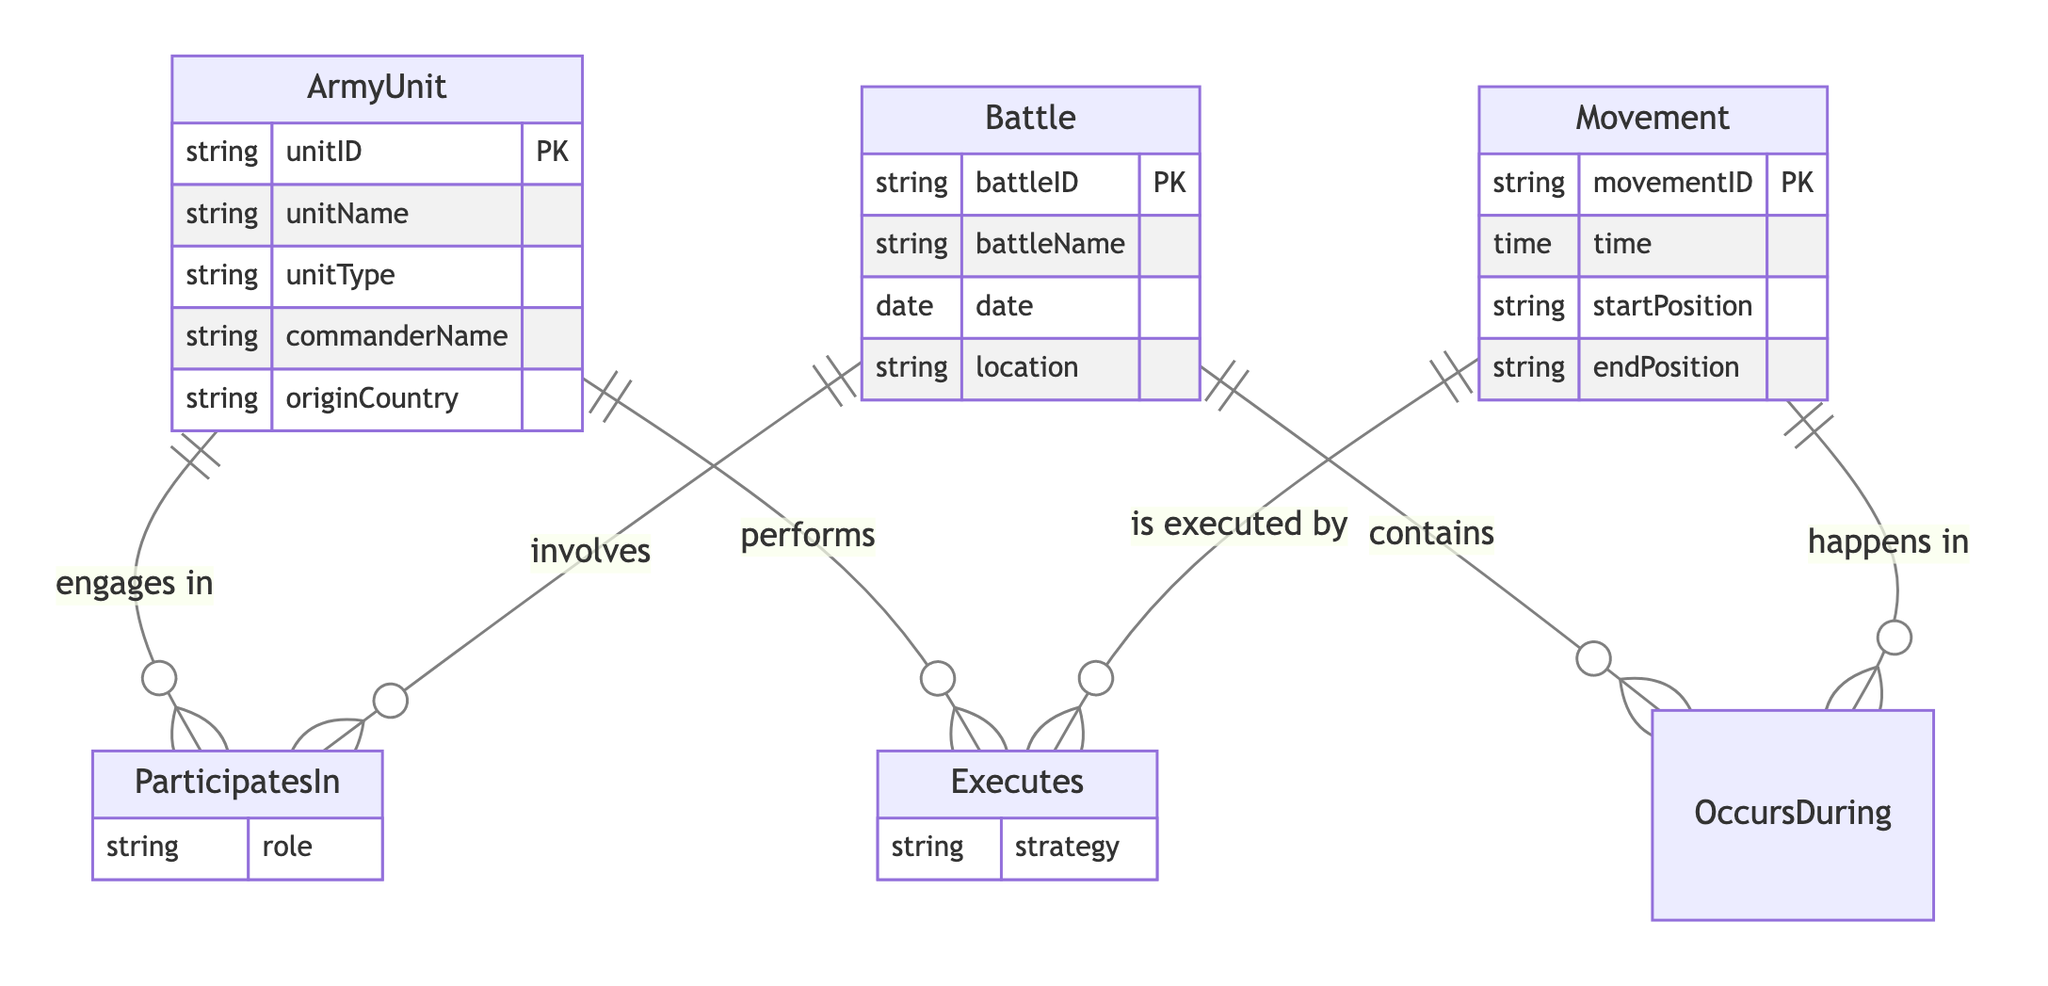what are the attributes of the Battle entity? The attributes for the Battle entity, as shown in the diagram, include battleID, battleName, date, and location.
Answer: battleID, battleName, date, location how many entities are in the diagram? By counting the entities in the diagram, we have three: ArmyUnit, Battle, and Movement.
Answer: 3 what type of relationship connects ArmyUnit and Battle? The relationship between ArmyUnit and Battle is "ParticipatesIn", which indicates that ArmyUnit engages in the Battle.
Answer: ParticipatesIn how many attributes does the Movement entity have? The Movement entity has four attributes: movementID, time, startPosition, and endPosition.
Answer: 4 what role does the ParticipatesIn relationship hold? The role attribute in the ParticipatesIn relationship provides information on the involvement of ArmyUnit in Battle.
Answer: role what is the relationship type between Movement and Battle? The relationship between Movement and Battle is "OccursDuring", which indicates that Movement happens in Battle.
Answer: OccursDuring how many relationships are depicted in the diagram? The diagram shows three relationships: ParticipatesIn, Executes, and OccursDuring, totaling three relationships.
Answer: 3 which entity is executed by the Movement entity? The Movement entity is executed by the ArmyUnit, as indicated by the Executes relationship in the diagram.
Answer: ArmyUnit what is the attribute associated with the Executes relationship? The Executes relationship includes the attribute strategy, which defines the nature of the execution from ArmyUnit in Movement.
Answer: strategy 